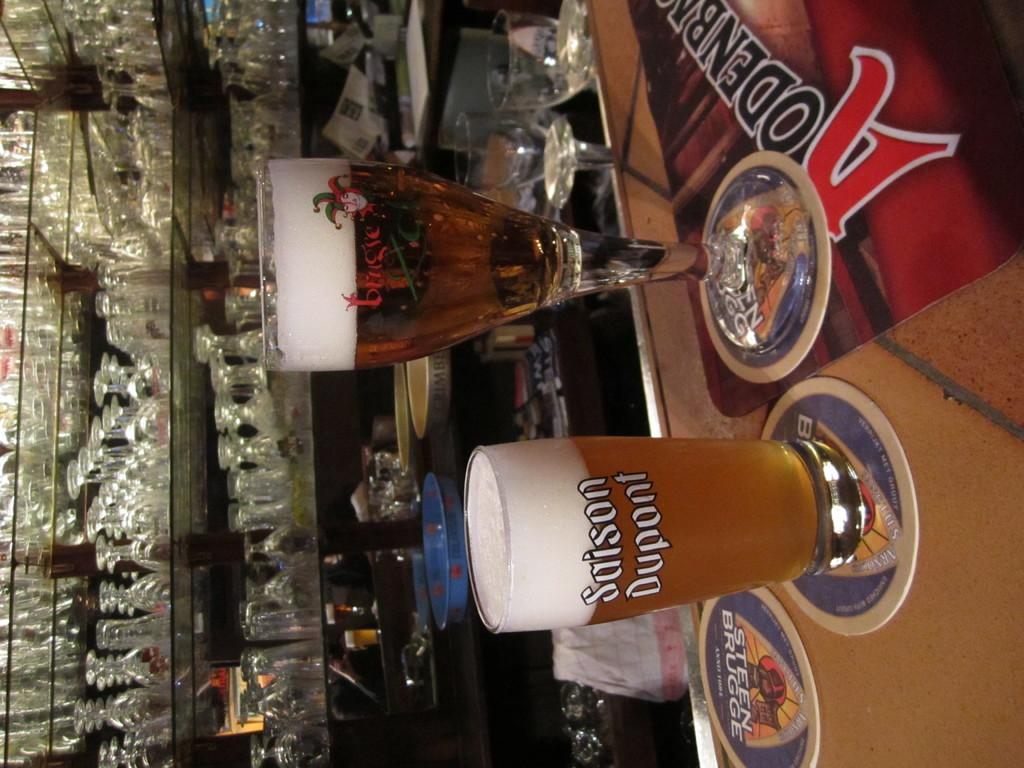<image>
Relay a brief, clear account of the picture shown. two glasses of beer with Sason dupont on the short one, are sitting on a bar 